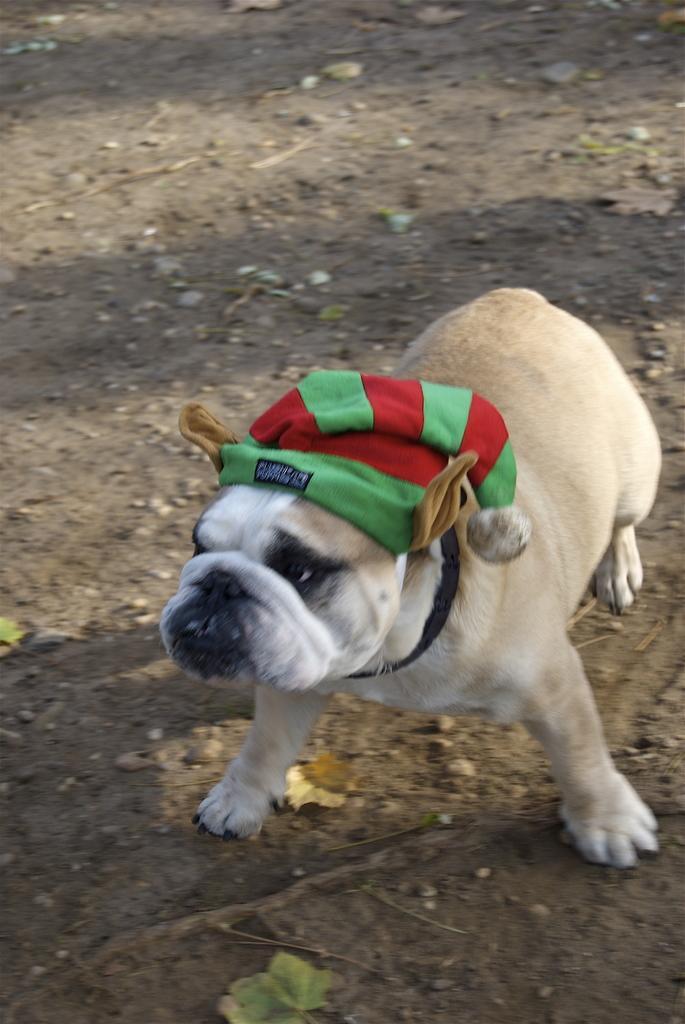In one or two sentences, can you explain what this image depicts? In this picture we can see a dog, at the bottom there is soil and some stones, we can see a cap here. 